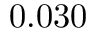<formula> <loc_0><loc_0><loc_500><loc_500>0 . 0 3 0</formula> 